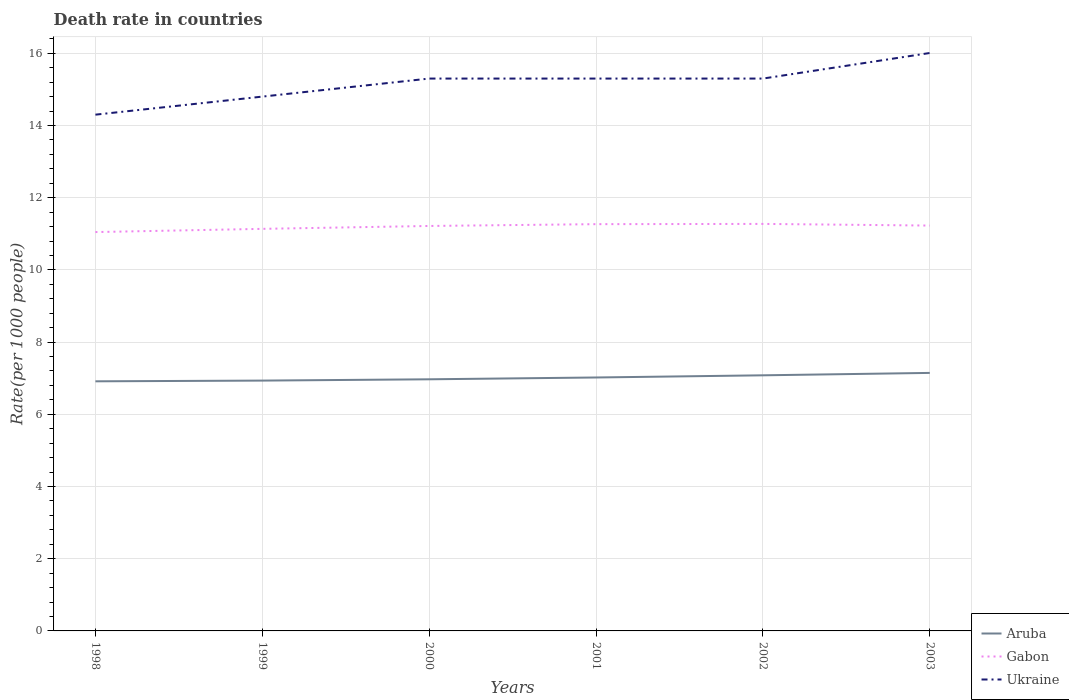Across all years, what is the maximum death rate in Gabon?
Your answer should be compact. 11.05. What is the total death rate in Gabon in the graph?
Offer a terse response. -0.17. What is the difference between the highest and the second highest death rate in Aruba?
Your response must be concise. 0.23. What is the difference between the highest and the lowest death rate in Gabon?
Offer a very short reply. 4. Is the death rate in Gabon strictly greater than the death rate in Aruba over the years?
Provide a succinct answer. No. What is the difference between two consecutive major ticks on the Y-axis?
Give a very brief answer. 2. Does the graph contain any zero values?
Offer a very short reply. No. Does the graph contain grids?
Provide a succinct answer. Yes. Where does the legend appear in the graph?
Make the answer very short. Bottom right. How many legend labels are there?
Keep it short and to the point. 3. What is the title of the graph?
Provide a succinct answer. Death rate in countries. What is the label or title of the Y-axis?
Ensure brevity in your answer.  Rate(per 1000 people). What is the Rate(per 1000 people) of Aruba in 1998?
Make the answer very short. 6.91. What is the Rate(per 1000 people) in Gabon in 1998?
Keep it short and to the point. 11.05. What is the Rate(per 1000 people) of Aruba in 1999?
Make the answer very short. 6.93. What is the Rate(per 1000 people) in Gabon in 1999?
Offer a very short reply. 11.14. What is the Rate(per 1000 people) of Ukraine in 1999?
Offer a terse response. 14.8. What is the Rate(per 1000 people) in Aruba in 2000?
Provide a short and direct response. 6.97. What is the Rate(per 1000 people) of Gabon in 2000?
Give a very brief answer. 11.22. What is the Rate(per 1000 people) in Aruba in 2001?
Your response must be concise. 7.02. What is the Rate(per 1000 people) of Gabon in 2001?
Give a very brief answer. 11.27. What is the Rate(per 1000 people) of Aruba in 2002?
Ensure brevity in your answer.  7.08. What is the Rate(per 1000 people) in Gabon in 2002?
Make the answer very short. 11.27. What is the Rate(per 1000 people) of Aruba in 2003?
Provide a short and direct response. 7.15. What is the Rate(per 1000 people) of Gabon in 2003?
Provide a short and direct response. 11.23. What is the Rate(per 1000 people) in Ukraine in 2003?
Your answer should be very brief. 16.01. Across all years, what is the maximum Rate(per 1000 people) in Aruba?
Offer a very short reply. 7.15. Across all years, what is the maximum Rate(per 1000 people) of Gabon?
Your answer should be compact. 11.27. Across all years, what is the maximum Rate(per 1000 people) of Ukraine?
Your answer should be very brief. 16.01. Across all years, what is the minimum Rate(per 1000 people) of Aruba?
Make the answer very short. 6.91. Across all years, what is the minimum Rate(per 1000 people) of Gabon?
Keep it short and to the point. 11.05. What is the total Rate(per 1000 people) in Aruba in the graph?
Keep it short and to the point. 42.06. What is the total Rate(per 1000 people) of Gabon in the graph?
Provide a short and direct response. 67.17. What is the total Rate(per 1000 people) of Ukraine in the graph?
Provide a succinct answer. 91.01. What is the difference between the Rate(per 1000 people) of Aruba in 1998 and that in 1999?
Make the answer very short. -0.02. What is the difference between the Rate(per 1000 people) in Gabon in 1998 and that in 1999?
Provide a short and direct response. -0.09. What is the difference between the Rate(per 1000 people) of Aruba in 1998 and that in 2000?
Provide a succinct answer. -0.06. What is the difference between the Rate(per 1000 people) of Gabon in 1998 and that in 2000?
Ensure brevity in your answer.  -0.17. What is the difference between the Rate(per 1000 people) of Aruba in 1998 and that in 2001?
Keep it short and to the point. -0.11. What is the difference between the Rate(per 1000 people) of Gabon in 1998 and that in 2001?
Keep it short and to the point. -0.22. What is the difference between the Rate(per 1000 people) of Aruba in 1998 and that in 2002?
Your answer should be compact. -0.17. What is the difference between the Rate(per 1000 people) of Gabon in 1998 and that in 2002?
Ensure brevity in your answer.  -0.23. What is the difference between the Rate(per 1000 people) of Ukraine in 1998 and that in 2002?
Provide a short and direct response. -1. What is the difference between the Rate(per 1000 people) in Aruba in 1998 and that in 2003?
Your answer should be compact. -0.23. What is the difference between the Rate(per 1000 people) in Gabon in 1998 and that in 2003?
Give a very brief answer. -0.18. What is the difference between the Rate(per 1000 people) in Ukraine in 1998 and that in 2003?
Your answer should be very brief. -1.71. What is the difference between the Rate(per 1000 people) in Aruba in 1999 and that in 2000?
Your answer should be very brief. -0.04. What is the difference between the Rate(per 1000 people) in Gabon in 1999 and that in 2000?
Provide a succinct answer. -0.08. What is the difference between the Rate(per 1000 people) in Ukraine in 1999 and that in 2000?
Provide a succinct answer. -0.5. What is the difference between the Rate(per 1000 people) in Aruba in 1999 and that in 2001?
Provide a succinct answer. -0.09. What is the difference between the Rate(per 1000 people) of Gabon in 1999 and that in 2001?
Your response must be concise. -0.13. What is the difference between the Rate(per 1000 people) in Aruba in 1999 and that in 2002?
Your answer should be compact. -0.15. What is the difference between the Rate(per 1000 people) of Gabon in 1999 and that in 2002?
Provide a short and direct response. -0.14. What is the difference between the Rate(per 1000 people) of Aruba in 1999 and that in 2003?
Your answer should be compact. -0.21. What is the difference between the Rate(per 1000 people) in Gabon in 1999 and that in 2003?
Provide a succinct answer. -0.09. What is the difference between the Rate(per 1000 people) of Ukraine in 1999 and that in 2003?
Offer a terse response. -1.21. What is the difference between the Rate(per 1000 people) in Aruba in 2000 and that in 2002?
Give a very brief answer. -0.11. What is the difference between the Rate(per 1000 people) in Gabon in 2000 and that in 2002?
Make the answer very short. -0.06. What is the difference between the Rate(per 1000 people) in Ukraine in 2000 and that in 2002?
Make the answer very short. 0. What is the difference between the Rate(per 1000 people) in Aruba in 2000 and that in 2003?
Your answer should be very brief. -0.18. What is the difference between the Rate(per 1000 people) in Gabon in 2000 and that in 2003?
Provide a short and direct response. -0.01. What is the difference between the Rate(per 1000 people) in Ukraine in 2000 and that in 2003?
Give a very brief answer. -0.71. What is the difference between the Rate(per 1000 people) in Aruba in 2001 and that in 2002?
Provide a succinct answer. -0.06. What is the difference between the Rate(per 1000 people) of Gabon in 2001 and that in 2002?
Give a very brief answer. -0.01. What is the difference between the Rate(per 1000 people) of Aruba in 2001 and that in 2003?
Keep it short and to the point. -0.13. What is the difference between the Rate(per 1000 people) in Gabon in 2001 and that in 2003?
Your response must be concise. 0.04. What is the difference between the Rate(per 1000 people) of Ukraine in 2001 and that in 2003?
Give a very brief answer. -0.71. What is the difference between the Rate(per 1000 people) of Aruba in 2002 and that in 2003?
Offer a terse response. -0.07. What is the difference between the Rate(per 1000 people) in Gabon in 2002 and that in 2003?
Keep it short and to the point. 0.05. What is the difference between the Rate(per 1000 people) in Ukraine in 2002 and that in 2003?
Make the answer very short. -0.71. What is the difference between the Rate(per 1000 people) in Aruba in 1998 and the Rate(per 1000 people) in Gabon in 1999?
Your answer should be very brief. -4.22. What is the difference between the Rate(per 1000 people) of Aruba in 1998 and the Rate(per 1000 people) of Ukraine in 1999?
Offer a terse response. -7.89. What is the difference between the Rate(per 1000 people) in Gabon in 1998 and the Rate(per 1000 people) in Ukraine in 1999?
Keep it short and to the point. -3.75. What is the difference between the Rate(per 1000 people) in Aruba in 1998 and the Rate(per 1000 people) in Gabon in 2000?
Offer a terse response. -4.3. What is the difference between the Rate(per 1000 people) of Aruba in 1998 and the Rate(per 1000 people) of Ukraine in 2000?
Your answer should be compact. -8.39. What is the difference between the Rate(per 1000 people) of Gabon in 1998 and the Rate(per 1000 people) of Ukraine in 2000?
Provide a short and direct response. -4.25. What is the difference between the Rate(per 1000 people) of Aruba in 1998 and the Rate(per 1000 people) of Gabon in 2001?
Your answer should be compact. -4.35. What is the difference between the Rate(per 1000 people) of Aruba in 1998 and the Rate(per 1000 people) of Ukraine in 2001?
Ensure brevity in your answer.  -8.39. What is the difference between the Rate(per 1000 people) in Gabon in 1998 and the Rate(per 1000 people) in Ukraine in 2001?
Provide a succinct answer. -4.25. What is the difference between the Rate(per 1000 people) in Aruba in 1998 and the Rate(per 1000 people) in Gabon in 2002?
Keep it short and to the point. -4.36. What is the difference between the Rate(per 1000 people) of Aruba in 1998 and the Rate(per 1000 people) of Ukraine in 2002?
Make the answer very short. -8.39. What is the difference between the Rate(per 1000 people) of Gabon in 1998 and the Rate(per 1000 people) of Ukraine in 2002?
Offer a very short reply. -4.25. What is the difference between the Rate(per 1000 people) in Aruba in 1998 and the Rate(per 1000 people) in Gabon in 2003?
Make the answer very short. -4.31. What is the difference between the Rate(per 1000 people) of Aruba in 1998 and the Rate(per 1000 people) of Ukraine in 2003?
Provide a short and direct response. -9.09. What is the difference between the Rate(per 1000 people) in Gabon in 1998 and the Rate(per 1000 people) in Ukraine in 2003?
Your answer should be compact. -4.96. What is the difference between the Rate(per 1000 people) in Aruba in 1999 and the Rate(per 1000 people) in Gabon in 2000?
Offer a terse response. -4.28. What is the difference between the Rate(per 1000 people) in Aruba in 1999 and the Rate(per 1000 people) in Ukraine in 2000?
Your answer should be very brief. -8.37. What is the difference between the Rate(per 1000 people) in Gabon in 1999 and the Rate(per 1000 people) in Ukraine in 2000?
Your answer should be very brief. -4.16. What is the difference between the Rate(per 1000 people) in Aruba in 1999 and the Rate(per 1000 people) in Gabon in 2001?
Give a very brief answer. -4.33. What is the difference between the Rate(per 1000 people) of Aruba in 1999 and the Rate(per 1000 people) of Ukraine in 2001?
Your answer should be very brief. -8.37. What is the difference between the Rate(per 1000 people) in Gabon in 1999 and the Rate(per 1000 people) in Ukraine in 2001?
Offer a very short reply. -4.16. What is the difference between the Rate(per 1000 people) in Aruba in 1999 and the Rate(per 1000 people) in Gabon in 2002?
Your answer should be compact. -4.34. What is the difference between the Rate(per 1000 people) of Aruba in 1999 and the Rate(per 1000 people) of Ukraine in 2002?
Provide a short and direct response. -8.37. What is the difference between the Rate(per 1000 people) of Gabon in 1999 and the Rate(per 1000 people) of Ukraine in 2002?
Offer a very short reply. -4.16. What is the difference between the Rate(per 1000 people) of Aruba in 1999 and the Rate(per 1000 people) of Gabon in 2003?
Your response must be concise. -4.29. What is the difference between the Rate(per 1000 people) in Aruba in 1999 and the Rate(per 1000 people) in Ukraine in 2003?
Offer a terse response. -9.07. What is the difference between the Rate(per 1000 people) of Gabon in 1999 and the Rate(per 1000 people) of Ukraine in 2003?
Offer a terse response. -4.87. What is the difference between the Rate(per 1000 people) of Aruba in 2000 and the Rate(per 1000 people) of Gabon in 2001?
Offer a very short reply. -4.3. What is the difference between the Rate(per 1000 people) of Aruba in 2000 and the Rate(per 1000 people) of Ukraine in 2001?
Provide a succinct answer. -8.33. What is the difference between the Rate(per 1000 people) of Gabon in 2000 and the Rate(per 1000 people) of Ukraine in 2001?
Your answer should be compact. -4.08. What is the difference between the Rate(per 1000 people) in Aruba in 2000 and the Rate(per 1000 people) in Gabon in 2002?
Your response must be concise. -4.3. What is the difference between the Rate(per 1000 people) in Aruba in 2000 and the Rate(per 1000 people) in Ukraine in 2002?
Keep it short and to the point. -8.33. What is the difference between the Rate(per 1000 people) in Gabon in 2000 and the Rate(per 1000 people) in Ukraine in 2002?
Your answer should be compact. -4.08. What is the difference between the Rate(per 1000 people) in Aruba in 2000 and the Rate(per 1000 people) in Gabon in 2003?
Your response must be concise. -4.26. What is the difference between the Rate(per 1000 people) in Aruba in 2000 and the Rate(per 1000 people) in Ukraine in 2003?
Your response must be concise. -9.04. What is the difference between the Rate(per 1000 people) of Gabon in 2000 and the Rate(per 1000 people) of Ukraine in 2003?
Make the answer very short. -4.79. What is the difference between the Rate(per 1000 people) of Aruba in 2001 and the Rate(per 1000 people) of Gabon in 2002?
Give a very brief answer. -4.25. What is the difference between the Rate(per 1000 people) of Aruba in 2001 and the Rate(per 1000 people) of Ukraine in 2002?
Offer a terse response. -8.28. What is the difference between the Rate(per 1000 people) in Gabon in 2001 and the Rate(per 1000 people) in Ukraine in 2002?
Keep it short and to the point. -4.03. What is the difference between the Rate(per 1000 people) of Aruba in 2001 and the Rate(per 1000 people) of Gabon in 2003?
Your response must be concise. -4.21. What is the difference between the Rate(per 1000 people) in Aruba in 2001 and the Rate(per 1000 people) in Ukraine in 2003?
Your answer should be very brief. -8.99. What is the difference between the Rate(per 1000 people) in Gabon in 2001 and the Rate(per 1000 people) in Ukraine in 2003?
Keep it short and to the point. -4.74. What is the difference between the Rate(per 1000 people) in Aruba in 2002 and the Rate(per 1000 people) in Gabon in 2003?
Offer a very short reply. -4.15. What is the difference between the Rate(per 1000 people) of Aruba in 2002 and the Rate(per 1000 people) of Ukraine in 2003?
Give a very brief answer. -8.93. What is the difference between the Rate(per 1000 people) in Gabon in 2002 and the Rate(per 1000 people) in Ukraine in 2003?
Give a very brief answer. -4.73. What is the average Rate(per 1000 people) of Aruba per year?
Ensure brevity in your answer.  7.01. What is the average Rate(per 1000 people) of Gabon per year?
Make the answer very short. 11.2. What is the average Rate(per 1000 people) in Ukraine per year?
Your answer should be very brief. 15.17. In the year 1998, what is the difference between the Rate(per 1000 people) in Aruba and Rate(per 1000 people) in Gabon?
Offer a very short reply. -4.13. In the year 1998, what is the difference between the Rate(per 1000 people) in Aruba and Rate(per 1000 people) in Ukraine?
Offer a very short reply. -7.39. In the year 1998, what is the difference between the Rate(per 1000 people) of Gabon and Rate(per 1000 people) of Ukraine?
Provide a succinct answer. -3.25. In the year 1999, what is the difference between the Rate(per 1000 people) of Aruba and Rate(per 1000 people) of Gabon?
Your answer should be compact. -4.2. In the year 1999, what is the difference between the Rate(per 1000 people) in Aruba and Rate(per 1000 people) in Ukraine?
Your answer should be compact. -7.87. In the year 1999, what is the difference between the Rate(per 1000 people) in Gabon and Rate(per 1000 people) in Ukraine?
Your answer should be very brief. -3.66. In the year 2000, what is the difference between the Rate(per 1000 people) of Aruba and Rate(per 1000 people) of Gabon?
Ensure brevity in your answer.  -4.25. In the year 2000, what is the difference between the Rate(per 1000 people) in Aruba and Rate(per 1000 people) in Ukraine?
Your answer should be compact. -8.33. In the year 2000, what is the difference between the Rate(per 1000 people) in Gabon and Rate(per 1000 people) in Ukraine?
Give a very brief answer. -4.08. In the year 2001, what is the difference between the Rate(per 1000 people) in Aruba and Rate(per 1000 people) in Gabon?
Offer a very short reply. -4.25. In the year 2001, what is the difference between the Rate(per 1000 people) of Aruba and Rate(per 1000 people) of Ukraine?
Make the answer very short. -8.28. In the year 2001, what is the difference between the Rate(per 1000 people) of Gabon and Rate(per 1000 people) of Ukraine?
Provide a short and direct response. -4.03. In the year 2002, what is the difference between the Rate(per 1000 people) in Aruba and Rate(per 1000 people) in Gabon?
Make the answer very short. -4.19. In the year 2002, what is the difference between the Rate(per 1000 people) of Aruba and Rate(per 1000 people) of Ukraine?
Offer a very short reply. -8.22. In the year 2002, what is the difference between the Rate(per 1000 people) in Gabon and Rate(per 1000 people) in Ukraine?
Provide a short and direct response. -4.03. In the year 2003, what is the difference between the Rate(per 1000 people) in Aruba and Rate(per 1000 people) in Gabon?
Provide a short and direct response. -4.08. In the year 2003, what is the difference between the Rate(per 1000 people) in Aruba and Rate(per 1000 people) in Ukraine?
Provide a short and direct response. -8.86. In the year 2003, what is the difference between the Rate(per 1000 people) in Gabon and Rate(per 1000 people) in Ukraine?
Offer a terse response. -4.78. What is the ratio of the Rate(per 1000 people) of Aruba in 1998 to that in 1999?
Make the answer very short. 1. What is the ratio of the Rate(per 1000 people) in Gabon in 1998 to that in 1999?
Your response must be concise. 0.99. What is the ratio of the Rate(per 1000 people) of Ukraine in 1998 to that in 1999?
Keep it short and to the point. 0.97. What is the ratio of the Rate(per 1000 people) of Aruba in 1998 to that in 2000?
Your answer should be compact. 0.99. What is the ratio of the Rate(per 1000 people) of Gabon in 1998 to that in 2000?
Offer a terse response. 0.98. What is the ratio of the Rate(per 1000 people) in Ukraine in 1998 to that in 2000?
Give a very brief answer. 0.93. What is the ratio of the Rate(per 1000 people) in Aruba in 1998 to that in 2001?
Offer a terse response. 0.98. What is the ratio of the Rate(per 1000 people) of Gabon in 1998 to that in 2001?
Your response must be concise. 0.98. What is the ratio of the Rate(per 1000 people) of Ukraine in 1998 to that in 2001?
Offer a very short reply. 0.93. What is the ratio of the Rate(per 1000 people) of Aruba in 1998 to that in 2002?
Give a very brief answer. 0.98. What is the ratio of the Rate(per 1000 people) of Gabon in 1998 to that in 2002?
Your answer should be very brief. 0.98. What is the ratio of the Rate(per 1000 people) of Ukraine in 1998 to that in 2002?
Provide a short and direct response. 0.93. What is the ratio of the Rate(per 1000 people) in Aruba in 1998 to that in 2003?
Keep it short and to the point. 0.97. What is the ratio of the Rate(per 1000 people) of Ukraine in 1998 to that in 2003?
Make the answer very short. 0.89. What is the ratio of the Rate(per 1000 people) of Gabon in 1999 to that in 2000?
Provide a succinct answer. 0.99. What is the ratio of the Rate(per 1000 people) of Ukraine in 1999 to that in 2000?
Your answer should be compact. 0.97. What is the ratio of the Rate(per 1000 people) in Ukraine in 1999 to that in 2001?
Provide a short and direct response. 0.97. What is the ratio of the Rate(per 1000 people) of Aruba in 1999 to that in 2002?
Provide a short and direct response. 0.98. What is the ratio of the Rate(per 1000 people) of Gabon in 1999 to that in 2002?
Offer a terse response. 0.99. What is the ratio of the Rate(per 1000 people) in Ukraine in 1999 to that in 2002?
Your answer should be compact. 0.97. What is the ratio of the Rate(per 1000 people) in Aruba in 1999 to that in 2003?
Offer a very short reply. 0.97. What is the ratio of the Rate(per 1000 people) of Ukraine in 1999 to that in 2003?
Give a very brief answer. 0.92. What is the ratio of the Rate(per 1000 people) of Aruba in 2000 to that in 2001?
Ensure brevity in your answer.  0.99. What is the ratio of the Rate(per 1000 people) of Ukraine in 2000 to that in 2001?
Ensure brevity in your answer.  1. What is the ratio of the Rate(per 1000 people) in Aruba in 2000 to that in 2002?
Ensure brevity in your answer.  0.98. What is the ratio of the Rate(per 1000 people) of Gabon in 2000 to that in 2002?
Provide a short and direct response. 0.99. What is the ratio of the Rate(per 1000 people) of Aruba in 2000 to that in 2003?
Offer a very short reply. 0.98. What is the ratio of the Rate(per 1000 people) in Gabon in 2000 to that in 2003?
Provide a short and direct response. 1. What is the ratio of the Rate(per 1000 people) in Ukraine in 2000 to that in 2003?
Ensure brevity in your answer.  0.96. What is the ratio of the Rate(per 1000 people) in Gabon in 2001 to that in 2002?
Your answer should be very brief. 1. What is the ratio of the Rate(per 1000 people) in Aruba in 2001 to that in 2003?
Keep it short and to the point. 0.98. What is the ratio of the Rate(per 1000 people) of Gabon in 2001 to that in 2003?
Offer a terse response. 1. What is the ratio of the Rate(per 1000 people) of Ukraine in 2001 to that in 2003?
Give a very brief answer. 0.96. What is the ratio of the Rate(per 1000 people) in Aruba in 2002 to that in 2003?
Your response must be concise. 0.99. What is the ratio of the Rate(per 1000 people) in Ukraine in 2002 to that in 2003?
Offer a terse response. 0.96. What is the difference between the highest and the second highest Rate(per 1000 people) in Aruba?
Provide a short and direct response. 0.07. What is the difference between the highest and the second highest Rate(per 1000 people) of Gabon?
Your response must be concise. 0.01. What is the difference between the highest and the second highest Rate(per 1000 people) of Ukraine?
Ensure brevity in your answer.  0.71. What is the difference between the highest and the lowest Rate(per 1000 people) in Aruba?
Your answer should be compact. 0.23. What is the difference between the highest and the lowest Rate(per 1000 people) in Gabon?
Make the answer very short. 0.23. What is the difference between the highest and the lowest Rate(per 1000 people) of Ukraine?
Ensure brevity in your answer.  1.71. 